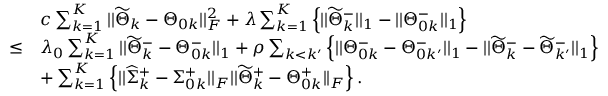Convert formula to latex. <formula><loc_0><loc_0><loc_500><loc_500>\begin{array} { r l } & { c \sum _ { k = 1 } ^ { K } | | \widetilde { \Theta } _ { k } - \Theta _ { 0 k } | | _ { F } ^ { 2 } + \lambda \sum _ { k = 1 } ^ { K } \left \{ | | \widetilde { \Theta } _ { k } ^ { - } | | _ { 1 } - | | \Theta _ { 0 k } ^ { - } | | _ { 1 } \right \} } \\ { \leq } & { \lambda _ { 0 } \sum _ { k = 1 } ^ { K } | | \widetilde { \Theta } _ { k } ^ { - } - \Theta _ { 0 k } ^ { - } | | _ { 1 } + \rho \sum _ { k < k ^ { \prime } } \left \{ | | \Theta _ { 0 k } ^ { - } - \Theta _ { 0 k ^ { \prime } } ^ { - } | | _ { 1 } - | | \widetilde { \Theta } _ { k } ^ { - } - \widetilde { \Theta } _ { k ^ { \prime } } ^ { - } | | _ { 1 } \right \} } \\ & { + \sum _ { k = 1 } ^ { K } \left \{ | | \widehat { \Sigma } _ { k } ^ { + } - \Sigma _ { 0 k } ^ { + } | | _ { F } | | \widetilde { \Theta } _ { k } ^ { + } - \Theta _ { 0 k } ^ { + } | | _ { F } \right \} . } \end{array}</formula> 